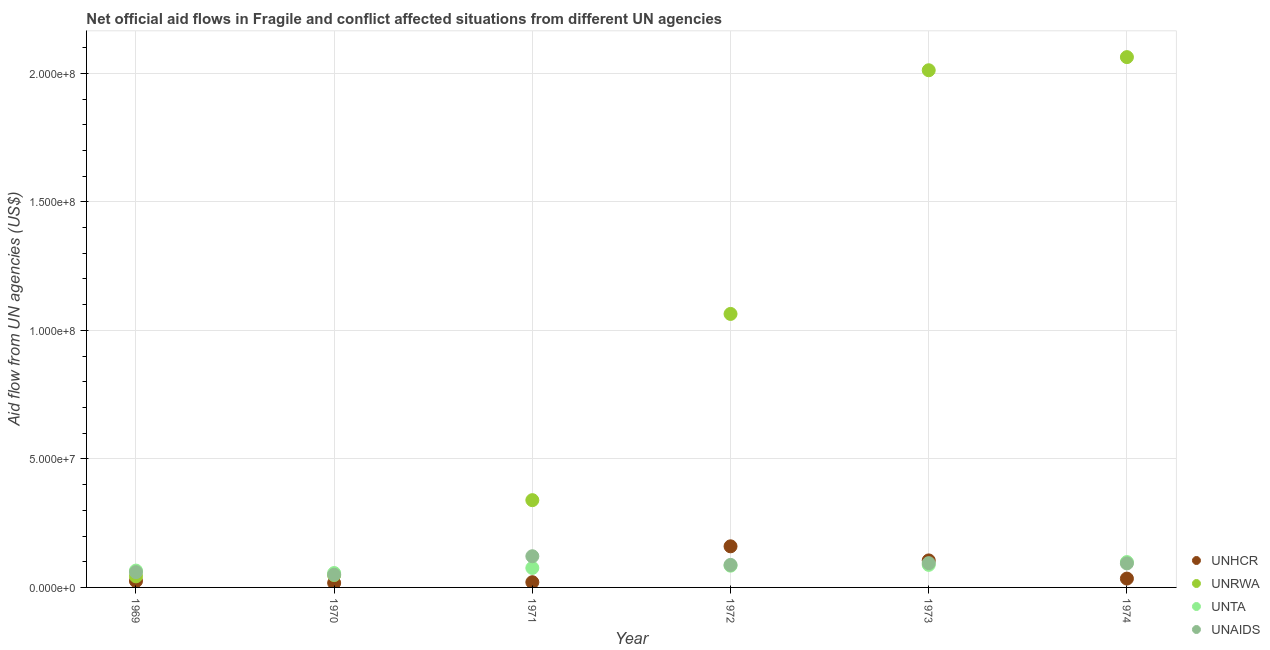What is the amount of aid given by unrwa in 1970?
Your answer should be very brief. 4.79e+06. Across all years, what is the maximum amount of aid given by unhcr?
Keep it short and to the point. 1.60e+07. Across all years, what is the minimum amount of aid given by unaids?
Your response must be concise. 4.94e+06. In which year was the amount of aid given by unta maximum?
Keep it short and to the point. 1974. In which year was the amount of aid given by unhcr minimum?
Offer a very short reply. 1970. What is the total amount of aid given by unrwa in the graph?
Offer a terse response. 5.57e+08. What is the difference between the amount of aid given by unhcr in 1969 and that in 1974?
Your answer should be compact. -9.60e+05. What is the difference between the amount of aid given by unta in 1973 and the amount of aid given by unrwa in 1971?
Make the answer very short. -2.52e+07. What is the average amount of aid given by unta per year?
Ensure brevity in your answer.  7.80e+06. In the year 1970, what is the difference between the amount of aid given by unaids and amount of aid given by unta?
Offer a very short reply. -6.50e+05. In how many years, is the amount of aid given by unta greater than 140000000 US$?
Your answer should be compact. 0. What is the ratio of the amount of aid given by unhcr in 1969 to that in 1972?
Provide a short and direct response. 0.16. What is the difference between the highest and the second highest amount of aid given by unaids?
Give a very brief answer. 2.68e+06. What is the difference between the highest and the lowest amount of aid given by unrwa?
Your answer should be very brief. 2.02e+08. In how many years, is the amount of aid given by unrwa greater than the average amount of aid given by unrwa taken over all years?
Your response must be concise. 3. Is the sum of the amount of aid given by unta in 1970 and 1972 greater than the maximum amount of aid given by unrwa across all years?
Give a very brief answer. No. Is it the case that in every year, the sum of the amount of aid given by unaids and amount of aid given by unta is greater than the sum of amount of aid given by unrwa and amount of aid given by unhcr?
Give a very brief answer. No. Does the amount of aid given by unrwa monotonically increase over the years?
Offer a terse response. Yes. Is the amount of aid given by unrwa strictly less than the amount of aid given by unaids over the years?
Give a very brief answer. No. How many dotlines are there?
Make the answer very short. 4. What is the difference between two consecutive major ticks on the Y-axis?
Offer a terse response. 5.00e+07. Are the values on the major ticks of Y-axis written in scientific E-notation?
Give a very brief answer. Yes. Does the graph contain any zero values?
Provide a short and direct response. No. Does the graph contain grids?
Offer a very short reply. Yes. How are the legend labels stacked?
Keep it short and to the point. Vertical. What is the title of the graph?
Your answer should be compact. Net official aid flows in Fragile and conflict affected situations from different UN agencies. What is the label or title of the X-axis?
Your answer should be compact. Year. What is the label or title of the Y-axis?
Offer a very short reply. Aid flow from UN agencies (US$). What is the Aid flow from UN agencies (US$) of UNHCR in 1969?
Make the answer very short. 2.48e+06. What is the Aid flow from UN agencies (US$) of UNRWA in 1969?
Your answer should be very brief. 4.30e+06. What is the Aid flow from UN agencies (US$) of UNTA in 1969?
Your answer should be compact. 6.55e+06. What is the Aid flow from UN agencies (US$) in UNAIDS in 1969?
Your answer should be very brief. 5.95e+06. What is the Aid flow from UN agencies (US$) of UNHCR in 1970?
Your answer should be compact. 1.74e+06. What is the Aid flow from UN agencies (US$) of UNRWA in 1970?
Make the answer very short. 4.79e+06. What is the Aid flow from UN agencies (US$) in UNTA in 1970?
Make the answer very short. 5.59e+06. What is the Aid flow from UN agencies (US$) in UNAIDS in 1970?
Your answer should be very brief. 4.94e+06. What is the Aid flow from UN agencies (US$) in UNHCR in 1971?
Provide a succinct answer. 2.03e+06. What is the Aid flow from UN agencies (US$) of UNRWA in 1971?
Offer a very short reply. 3.40e+07. What is the Aid flow from UN agencies (US$) in UNTA in 1971?
Make the answer very short. 7.58e+06. What is the Aid flow from UN agencies (US$) in UNAIDS in 1971?
Provide a short and direct response. 1.21e+07. What is the Aid flow from UN agencies (US$) in UNHCR in 1972?
Offer a very short reply. 1.60e+07. What is the Aid flow from UN agencies (US$) in UNRWA in 1972?
Give a very brief answer. 1.06e+08. What is the Aid flow from UN agencies (US$) in UNTA in 1972?
Offer a terse response. 8.46e+06. What is the Aid flow from UN agencies (US$) in UNAIDS in 1972?
Provide a short and direct response. 8.76e+06. What is the Aid flow from UN agencies (US$) in UNHCR in 1973?
Provide a succinct answer. 1.05e+07. What is the Aid flow from UN agencies (US$) of UNRWA in 1973?
Your response must be concise. 2.01e+08. What is the Aid flow from UN agencies (US$) in UNTA in 1973?
Keep it short and to the point. 8.78e+06. What is the Aid flow from UN agencies (US$) of UNAIDS in 1973?
Offer a very short reply. 9.45e+06. What is the Aid flow from UN agencies (US$) of UNHCR in 1974?
Provide a short and direct response. 3.44e+06. What is the Aid flow from UN agencies (US$) in UNRWA in 1974?
Your answer should be very brief. 2.06e+08. What is the Aid flow from UN agencies (US$) in UNTA in 1974?
Your answer should be very brief. 9.86e+06. What is the Aid flow from UN agencies (US$) in UNAIDS in 1974?
Your answer should be compact. 9.35e+06. Across all years, what is the maximum Aid flow from UN agencies (US$) of UNHCR?
Keep it short and to the point. 1.60e+07. Across all years, what is the maximum Aid flow from UN agencies (US$) of UNRWA?
Give a very brief answer. 2.06e+08. Across all years, what is the maximum Aid flow from UN agencies (US$) in UNTA?
Ensure brevity in your answer.  9.86e+06. Across all years, what is the maximum Aid flow from UN agencies (US$) of UNAIDS?
Keep it short and to the point. 1.21e+07. Across all years, what is the minimum Aid flow from UN agencies (US$) in UNHCR?
Keep it short and to the point. 1.74e+06. Across all years, what is the minimum Aid flow from UN agencies (US$) of UNRWA?
Offer a very short reply. 4.30e+06. Across all years, what is the minimum Aid flow from UN agencies (US$) of UNTA?
Provide a short and direct response. 5.59e+06. Across all years, what is the minimum Aid flow from UN agencies (US$) in UNAIDS?
Your response must be concise. 4.94e+06. What is the total Aid flow from UN agencies (US$) in UNHCR in the graph?
Offer a terse response. 3.62e+07. What is the total Aid flow from UN agencies (US$) in UNRWA in the graph?
Your response must be concise. 5.57e+08. What is the total Aid flow from UN agencies (US$) of UNTA in the graph?
Keep it short and to the point. 4.68e+07. What is the total Aid flow from UN agencies (US$) in UNAIDS in the graph?
Keep it short and to the point. 5.06e+07. What is the difference between the Aid flow from UN agencies (US$) in UNHCR in 1969 and that in 1970?
Your answer should be compact. 7.40e+05. What is the difference between the Aid flow from UN agencies (US$) of UNRWA in 1969 and that in 1970?
Provide a short and direct response. -4.90e+05. What is the difference between the Aid flow from UN agencies (US$) of UNTA in 1969 and that in 1970?
Your answer should be compact. 9.60e+05. What is the difference between the Aid flow from UN agencies (US$) of UNAIDS in 1969 and that in 1970?
Your answer should be compact. 1.01e+06. What is the difference between the Aid flow from UN agencies (US$) of UNHCR in 1969 and that in 1971?
Offer a very short reply. 4.50e+05. What is the difference between the Aid flow from UN agencies (US$) of UNRWA in 1969 and that in 1971?
Ensure brevity in your answer.  -2.96e+07. What is the difference between the Aid flow from UN agencies (US$) of UNTA in 1969 and that in 1971?
Ensure brevity in your answer.  -1.03e+06. What is the difference between the Aid flow from UN agencies (US$) of UNAIDS in 1969 and that in 1971?
Ensure brevity in your answer.  -6.18e+06. What is the difference between the Aid flow from UN agencies (US$) in UNHCR in 1969 and that in 1972?
Give a very brief answer. -1.35e+07. What is the difference between the Aid flow from UN agencies (US$) in UNRWA in 1969 and that in 1972?
Keep it short and to the point. -1.02e+08. What is the difference between the Aid flow from UN agencies (US$) in UNTA in 1969 and that in 1972?
Your answer should be compact. -1.91e+06. What is the difference between the Aid flow from UN agencies (US$) of UNAIDS in 1969 and that in 1972?
Your answer should be very brief. -2.81e+06. What is the difference between the Aid flow from UN agencies (US$) of UNHCR in 1969 and that in 1973?
Your answer should be compact. -8.03e+06. What is the difference between the Aid flow from UN agencies (US$) in UNRWA in 1969 and that in 1973?
Your response must be concise. -1.97e+08. What is the difference between the Aid flow from UN agencies (US$) of UNTA in 1969 and that in 1973?
Make the answer very short. -2.23e+06. What is the difference between the Aid flow from UN agencies (US$) in UNAIDS in 1969 and that in 1973?
Offer a terse response. -3.50e+06. What is the difference between the Aid flow from UN agencies (US$) in UNHCR in 1969 and that in 1974?
Offer a very short reply. -9.60e+05. What is the difference between the Aid flow from UN agencies (US$) of UNRWA in 1969 and that in 1974?
Offer a very short reply. -2.02e+08. What is the difference between the Aid flow from UN agencies (US$) of UNTA in 1969 and that in 1974?
Your answer should be very brief. -3.31e+06. What is the difference between the Aid flow from UN agencies (US$) in UNAIDS in 1969 and that in 1974?
Provide a short and direct response. -3.40e+06. What is the difference between the Aid flow from UN agencies (US$) of UNHCR in 1970 and that in 1971?
Your response must be concise. -2.90e+05. What is the difference between the Aid flow from UN agencies (US$) in UNRWA in 1970 and that in 1971?
Provide a short and direct response. -2.92e+07. What is the difference between the Aid flow from UN agencies (US$) in UNTA in 1970 and that in 1971?
Your answer should be compact. -1.99e+06. What is the difference between the Aid flow from UN agencies (US$) in UNAIDS in 1970 and that in 1971?
Ensure brevity in your answer.  -7.19e+06. What is the difference between the Aid flow from UN agencies (US$) of UNHCR in 1970 and that in 1972?
Provide a short and direct response. -1.42e+07. What is the difference between the Aid flow from UN agencies (US$) in UNRWA in 1970 and that in 1972?
Offer a terse response. -1.02e+08. What is the difference between the Aid flow from UN agencies (US$) of UNTA in 1970 and that in 1972?
Offer a very short reply. -2.87e+06. What is the difference between the Aid flow from UN agencies (US$) of UNAIDS in 1970 and that in 1972?
Your answer should be very brief. -3.82e+06. What is the difference between the Aid flow from UN agencies (US$) in UNHCR in 1970 and that in 1973?
Provide a succinct answer. -8.77e+06. What is the difference between the Aid flow from UN agencies (US$) in UNRWA in 1970 and that in 1973?
Ensure brevity in your answer.  -1.96e+08. What is the difference between the Aid flow from UN agencies (US$) of UNTA in 1970 and that in 1973?
Offer a very short reply. -3.19e+06. What is the difference between the Aid flow from UN agencies (US$) of UNAIDS in 1970 and that in 1973?
Make the answer very short. -4.51e+06. What is the difference between the Aid flow from UN agencies (US$) in UNHCR in 1970 and that in 1974?
Give a very brief answer. -1.70e+06. What is the difference between the Aid flow from UN agencies (US$) of UNRWA in 1970 and that in 1974?
Ensure brevity in your answer.  -2.02e+08. What is the difference between the Aid flow from UN agencies (US$) in UNTA in 1970 and that in 1974?
Your answer should be very brief. -4.27e+06. What is the difference between the Aid flow from UN agencies (US$) in UNAIDS in 1970 and that in 1974?
Your answer should be very brief. -4.41e+06. What is the difference between the Aid flow from UN agencies (US$) of UNHCR in 1971 and that in 1972?
Provide a succinct answer. -1.40e+07. What is the difference between the Aid flow from UN agencies (US$) of UNRWA in 1971 and that in 1972?
Make the answer very short. -7.24e+07. What is the difference between the Aid flow from UN agencies (US$) of UNTA in 1971 and that in 1972?
Your response must be concise. -8.80e+05. What is the difference between the Aid flow from UN agencies (US$) of UNAIDS in 1971 and that in 1972?
Ensure brevity in your answer.  3.37e+06. What is the difference between the Aid flow from UN agencies (US$) in UNHCR in 1971 and that in 1973?
Your answer should be compact. -8.48e+06. What is the difference between the Aid flow from UN agencies (US$) of UNRWA in 1971 and that in 1973?
Your answer should be very brief. -1.67e+08. What is the difference between the Aid flow from UN agencies (US$) of UNTA in 1971 and that in 1973?
Your answer should be compact. -1.20e+06. What is the difference between the Aid flow from UN agencies (US$) in UNAIDS in 1971 and that in 1973?
Give a very brief answer. 2.68e+06. What is the difference between the Aid flow from UN agencies (US$) of UNHCR in 1971 and that in 1974?
Make the answer very short. -1.41e+06. What is the difference between the Aid flow from UN agencies (US$) of UNRWA in 1971 and that in 1974?
Your answer should be very brief. -1.72e+08. What is the difference between the Aid flow from UN agencies (US$) of UNTA in 1971 and that in 1974?
Provide a succinct answer. -2.28e+06. What is the difference between the Aid flow from UN agencies (US$) of UNAIDS in 1971 and that in 1974?
Ensure brevity in your answer.  2.78e+06. What is the difference between the Aid flow from UN agencies (US$) in UNHCR in 1972 and that in 1973?
Your answer should be very brief. 5.48e+06. What is the difference between the Aid flow from UN agencies (US$) in UNRWA in 1972 and that in 1973?
Your answer should be very brief. -9.48e+07. What is the difference between the Aid flow from UN agencies (US$) of UNTA in 1972 and that in 1973?
Keep it short and to the point. -3.20e+05. What is the difference between the Aid flow from UN agencies (US$) of UNAIDS in 1972 and that in 1973?
Keep it short and to the point. -6.90e+05. What is the difference between the Aid flow from UN agencies (US$) of UNHCR in 1972 and that in 1974?
Make the answer very short. 1.26e+07. What is the difference between the Aid flow from UN agencies (US$) of UNRWA in 1972 and that in 1974?
Offer a terse response. -9.99e+07. What is the difference between the Aid flow from UN agencies (US$) of UNTA in 1972 and that in 1974?
Offer a terse response. -1.40e+06. What is the difference between the Aid flow from UN agencies (US$) in UNAIDS in 1972 and that in 1974?
Keep it short and to the point. -5.90e+05. What is the difference between the Aid flow from UN agencies (US$) in UNHCR in 1973 and that in 1974?
Keep it short and to the point. 7.07e+06. What is the difference between the Aid flow from UN agencies (US$) of UNRWA in 1973 and that in 1974?
Your answer should be very brief. -5.11e+06. What is the difference between the Aid flow from UN agencies (US$) of UNTA in 1973 and that in 1974?
Keep it short and to the point. -1.08e+06. What is the difference between the Aid flow from UN agencies (US$) of UNHCR in 1969 and the Aid flow from UN agencies (US$) of UNRWA in 1970?
Provide a short and direct response. -2.31e+06. What is the difference between the Aid flow from UN agencies (US$) of UNHCR in 1969 and the Aid flow from UN agencies (US$) of UNTA in 1970?
Ensure brevity in your answer.  -3.11e+06. What is the difference between the Aid flow from UN agencies (US$) of UNHCR in 1969 and the Aid flow from UN agencies (US$) of UNAIDS in 1970?
Give a very brief answer. -2.46e+06. What is the difference between the Aid flow from UN agencies (US$) in UNRWA in 1969 and the Aid flow from UN agencies (US$) in UNTA in 1970?
Make the answer very short. -1.29e+06. What is the difference between the Aid flow from UN agencies (US$) in UNRWA in 1969 and the Aid flow from UN agencies (US$) in UNAIDS in 1970?
Ensure brevity in your answer.  -6.40e+05. What is the difference between the Aid flow from UN agencies (US$) of UNTA in 1969 and the Aid flow from UN agencies (US$) of UNAIDS in 1970?
Offer a very short reply. 1.61e+06. What is the difference between the Aid flow from UN agencies (US$) in UNHCR in 1969 and the Aid flow from UN agencies (US$) in UNRWA in 1971?
Your answer should be very brief. -3.15e+07. What is the difference between the Aid flow from UN agencies (US$) in UNHCR in 1969 and the Aid flow from UN agencies (US$) in UNTA in 1971?
Provide a succinct answer. -5.10e+06. What is the difference between the Aid flow from UN agencies (US$) in UNHCR in 1969 and the Aid flow from UN agencies (US$) in UNAIDS in 1971?
Make the answer very short. -9.65e+06. What is the difference between the Aid flow from UN agencies (US$) in UNRWA in 1969 and the Aid flow from UN agencies (US$) in UNTA in 1971?
Your answer should be very brief. -3.28e+06. What is the difference between the Aid flow from UN agencies (US$) of UNRWA in 1969 and the Aid flow from UN agencies (US$) of UNAIDS in 1971?
Keep it short and to the point. -7.83e+06. What is the difference between the Aid flow from UN agencies (US$) in UNTA in 1969 and the Aid flow from UN agencies (US$) in UNAIDS in 1971?
Offer a terse response. -5.58e+06. What is the difference between the Aid flow from UN agencies (US$) of UNHCR in 1969 and the Aid flow from UN agencies (US$) of UNRWA in 1972?
Provide a succinct answer. -1.04e+08. What is the difference between the Aid flow from UN agencies (US$) in UNHCR in 1969 and the Aid flow from UN agencies (US$) in UNTA in 1972?
Keep it short and to the point. -5.98e+06. What is the difference between the Aid flow from UN agencies (US$) in UNHCR in 1969 and the Aid flow from UN agencies (US$) in UNAIDS in 1972?
Provide a short and direct response. -6.28e+06. What is the difference between the Aid flow from UN agencies (US$) of UNRWA in 1969 and the Aid flow from UN agencies (US$) of UNTA in 1972?
Your answer should be compact. -4.16e+06. What is the difference between the Aid flow from UN agencies (US$) of UNRWA in 1969 and the Aid flow from UN agencies (US$) of UNAIDS in 1972?
Provide a succinct answer. -4.46e+06. What is the difference between the Aid flow from UN agencies (US$) in UNTA in 1969 and the Aid flow from UN agencies (US$) in UNAIDS in 1972?
Offer a very short reply. -2.21e+06. What is the difference between the Aid flow from UN agencies (US$) of UNHCR in 1969 and the Aid flow from UN agencies (US$) of UNRWA in 1973?
Make the answer very short. -1.99e+08. What is the difference between the Aid flow from UN agencies (US$) in UNHCR in 1969 and the Aid flow from UN agencies (US$) in UNTA in 1973?
Offer a very short reply. -6.30e+06. What is the difference between the Aid flow from UN agencies (US$) of UNHCR in 1969 and the Aid flow from UN agencies (US$) of UNAIDS in 1973?
Your response must be concise. -6.97e+06. What is the difference between the Aid flow from UN agencies (US$) of UNRWA in 1969 and the Aid flow from UN agencies (US$) of UNTA in 1973?
Your answer should be compact. -4.48e+06. What is the difference between the Aid flow from UN agencies (US$) of UNRWA in 1969 and the Aid flow from UN agencies (US$) of UNAIDS in 1973?
Offer a very short reply. -5.15e+06. What is the difference between the Aid flow from UN agencies (US$) in UNTA in 1969 and the Aid flow from UN agencies (US$) in UNAIDS in 1973?
Keep it short and to the point. -2.90e+06. What is the difference between the Aid flow from UN agencies (US$) in UNHCR in 1969 and the Aid flow from UN agencies (US$) in UNRWA in 1974?
Provide a succinct answer. -2.04e+08. What is the difference between the Aid flow from UN agencies (US$) of UNHCR in 1969 and the Aid flow from UN agencies (US$) of UNTA in 1974?
Ensure brevity in your answer.  -7.38e+06. What is the difference between the Aid flow from UN agencies (US$) of UNHCR in 1969 and the Aid flow from UN agencies (US$) of UNAIDS in 1974?
Make the answer very short. -6.87e+06. What is the difference between the Aid flow from UN agencies (US$) of UNRWA in 1969 and the Aid flow from UN agencies (US$) of UNTA in 1974?
Make the answer very short. -5.56e+06. What is the difference between the Aid flow from UN agencies (US$) of UNRWA in 1969 and the Aid flow from UN agencies (US$) of UNAIDS in 1974?
Make the answer very short. -5.05e+06. What is the difference between the Aid flow from UN agencies (US$) of UNTA in 1969 and the Aid flow from UN agencies (US$) of UNAIDS in 1974?
Offer a very short reply. -2.80e+06. What is the difference between the Aid flow from UN agencies (US$) in UNHCR in 1970 and the Aid flow from UN agencies (US$) in UNRWA in 1971?
Offer a terse response. -3.22e+07. What is the difference between the Aid flow from UN agencies (US$) of UNHCR in 1970 and the Aid flow from UN agencies (US$) of UNTA in 1971?
Ensure brevity in your answer.  -5.84e+06. What is the difference between the Aid flow from UN agencies (US$) in UNHCR in 1970 and the Aid flow from UN agencies (US$) in UNAIDS in 1971?
Offer a very short reply. -1.04e+07. What is the difference between the Aid flow from UN agencies (US$) in UNRWA in 1970 and the Aid flow from UN agencies (US$) in UNTA in 1971?
Ensure brevity in your answer.  -2.79e+06. What is the difference between the Aid flow from UN agencies (US$) of UNRWA in 1970 and the Aid flow from UN agencies (US$) of UNAIDS in 1971?
Make the answer very short. -7.34e+06. What is the difference between the Aid flow from UN agencies (US$) in UNTA in 1970 and the Aid flow from UN agencies (US$) in UNAIDS in 1971?
Give a very brief answer. -6.54e+06. What is the difference between the Aid flow from UN agencies (US$) of UNHCR in 1970 and the Aid flow from UN agencies (US$) of UNRWA in 1972?
Your answer should be compact. -1.05e+08. What is the difference between the Aid flow from UN agencies (US$) of UNHCR in 1970 and the Aid flow from UN agencies (US$) of UNTA in 1972?
Provide a short and direct response. -6.72e+06. What is the difference between the Aid flow from UN agencies (US$) of UNHCR in 1970 and the Aid flow from UN agencies (US$) of UNAIDS in 1972?
Give a very brief answer. -7.02e+06. What is the difference between the Aid flow from UN agencies (US$) in UNRWA in 1970 and the Aid flow from UN agencies (US$) in UNTA in 1972?
Your response must be concise. -3.67e+06. What is the difference between the Aid flow from UN agencies (US$) in UNRWA in 1970 and the Aid flow from UN agencies (US$) in UNAIDS in 1972?
Ensure brevity in your answer.  -3.97e+06. What is the difference between the Aid flow from UN agencies (US$) of UNTA in 1970 and the Aid flow from UN agencies (US$) of UNAIDS in 1972?
Make the answer very short. -3.17e+06. What is the difference between the Aid flow from UN agencies (US$) in UNHCR in 1970 and the Aid flow from UN agencies (US$) in UNRWA in 1973?
Ensure brevity in your answer.  -1.99e+08. What is the difference between the Aid flow from UN agencies (US$) of UNHCR in 1970 and the Aid flow from UN agencies (US$) of UNTA in 1973?
Provide a short and direct response. -7.04e+06. What is the difference between the Aid flow from UN agencies (US$) of UNHCR in 1970 and the Aid flow from UN agencies (US$) of UNAIDS in 1973?
Give a very brief answer. -7.71e+06. What is the difference between the Aid flow from UN agencies (US$) of UNRWA in 1970 and the Aid flow from UN agencies (US$) of UNTA in 1973?
Your answer should be compact. -3.99e+06. What is the difference between the Aid flow from UN agencies (US$) in UNRWA in 1970 and the Aid flow from UN agencies (US$) in UNAIDS in 1973?
Give a very brief answer. -4.66e+06. What is the difference between the Aid flow from UN agencies (US$) of UNTA in 1970 and the Aid flow from UN agencies (US$) of UNAIDS in 1973?
Make the answer very short. -3.86e+06. What is the difference between the Aid flow from UN agencies (US$) in UNHCR in 1970 and the Aid flow from UN agencies (US$) in UNRWA in 1974?
Your answer should be very brief. -2.05e+08. What is the difference between the Aid flow from UN agencies (US$) in UNHCR in 1970 and the Aid flow from UN agencies (US$) in UNTA in 1974?
Offer a very short reply. -8.12e+06. What is the difference between the Aid flow from UN agencies (US$) in UNHCR in 1970 and the Aid flow from UN agencies (US$) in UNAIDS in 1974?
Keep it short and to the point. -7.61e+06. What is the difference between the Aid flow from UN agencies (US$) of UNRWA in 1970 and the Aid flow from UN agencies (US$) of UNTA in 1974?
Ensure brevity in your answer.  -5.07e+06. What is the difference between the Aid flow from UN agencies (US$) of UNRWA in 1970 and the Aid flow from UN agencies (US$) of UNAIDS in 1974?
Offer a terse response. -4.56e+06. What is the difference between the Aid flow from UN agencies (US$) of UNTA in 1970 and the Aid flow from UN agencies (US$) of UNAIDS in 1974?
Make the answer very short. -3.76e+06. What is the difference between the Aid flow from UN agencies (US$) in UNHCR in 1971 and the Aid flow from UN agencies (US$) in UNRWA in 1972?
Provide a short and direct response. -1.04e+08. What is the difference between the Aid flow from UN agencies (US$) of UNHCR in 1971 and the Aid flow from UN agencies (US$) of UNTA in 1972?
Keep it short and to the point. -6.43e+06. What is the difference between the Aid flow from UN agencies (US$) of UNHCR in 1971 and the Aid flow from UN agencies (US$) of UNAIDS in 1972?
Provide a short and direct response. -6.73e+06. What is the difference between the Aid flow from UN agencies (US$) of UNRWA in 1971 and the Aid flow from UN agencies (US$) of UNTA in 1972?
Offer a very short reply. 2.55e+07. What is the difference between the Aid flow from UN agencies (US$) of UNRWA in 1971 and the Aid flow from UN agencies (US$) of UNAIDS in 1972?
Ensure brevity in your answer.  2.52e+07. What is the difference between the Aid flow from UN agencies (US$) in UNTA in 1971 and the Aid flow from UN agencies (US$) in UNAIDS in 1972?
Offer a terse response. -1.18e+06. What is the difference between the Aid flow from UN agencies (US$) of UNHCR in 1971 and the Aid flow from UN agencies (US$) of UNRWA in 1973?
Your answer should be very brief. -1.99e+08. What is the difference between the Aid flow from UN agencies (US$) in UNHCR in 1971 and the Aid flow from UN agencies (US$) in UNTA in 1973?
Provide a short and direct response. -6.75e+06. What is the difference between the Aid flow from UN agencies (US$) of UNHCR in 1971 and the Aid flow from UN agencies (US$) of UNAIDS in 1973?
Provide a short and direct response. -7.42e+06. What is the difference between the Aid flow from UN agencies (US$) in UNRWA in 1971 and the Aid flow from UN agencies (US$) in UNTA in 1973?
Make the answer very short. 2.52e+07. What is the difference between the Aid flow from UN agencies (US$) of UNRWA in 1971 and the Aid flow from UN agencies (US$) of UNAIDS in 1973?
Your answer should be compact. 2.45e+07. What is the difference between the Aid flow from UN agencies (US$) of UNTA in 1971 and the Aid flow from UN agencies (US$) of UNAIDS in 1973?
Provide a short and direct response. -1.87e+06. What is the difference between the Aid flow from UN agencies (US$) in UNHCR in 1971 and the Aid flow from UN agencies (US$) in UNRWA in 1974?
Give a very brief answer. -2.04e+08. What is the difference between the Aid flow from UN agencies (US$) of UNHCR in 1971 and the Aid flow from UN agencies (US$) of UNTA in 1974?
Keep it short and to the point. -7.83e+06. What is the difference between the Aid flow from UN agencies (US$) in UNHCR in 1971 and the Aid flow from UN agencies (US$) in UNAIDS in 1974?
Your answer should be very brief. -7.32e+06. What is the difference between the Aid flow from UN agencies (US$) of UNRWA in 1971 and the Aid flow from UN agencies (US$) of UNTA in 1974?
Your answer should be very brief. 2.41e+07. What is the difference between the Aid flow from UN agencies (US$) in UNRWA in 1971 and the Aid flow from UN agencies (US$) in UNAIDS in 1974?
Your answer should be compact. 2.46e+07. What is the difference between the Aid flow from UN agencies (US$) of UNTA in 1971 and the Aid flow from UN agencies (US$) of UNAIDS in 1974?
Your response must be concise. -1.77e+06. What is the difference between the Aid flow from UN agencies (US$) in UNHCR in 1972 and the Aid flow from UN agencies (US$) in UNRWA in 1973?
Provide a succinct answer. -1.85e+08. What is the difference between the Aid flow from UN agencies (US$) in UNHCR in 1972 and the Aid flow from UN agencies (US$) in UNTA in 1973?
Provide a short and direct response. 7.21e+06. What is the difference between the Aid flow from UN agencies (US$) in UNHCR in 1972 and the Aid flow from UN agencies (US$) in UNAIDS in 1973?
Give a very brief answer. 6.54e+06. What is the difference between the Aid flow from UN agencies (US$) of UNRWA in 1972 and the Aid flow from UN agencies (US$) of UNTA in 1973?
Your answer should be very brief. 9.76e+07. What is the difference between the Aid flow from UN agencies (US$) in UNRWA in 1972 and the Aid flow from UN agencies (US$) in UNAIDS in 1973?
Your response must be concise. 9.70e+07. What is the difference between the Aid flow from UN agencies (US$) of UNTA in 1972 and the Aid flow from UN agencies (US$) of UNAIDS in 1973?
Ensure brevity in your answer.  -9.90e+05. What is the difference between the Aid flow from UN agencies (US$) in UNHCR in 1972 and the Aid flow from UN agencies (US$) in UNRWA in 1974?
Provide a succinct answer. -1.90e+08. What is the difference between the Aid flow from UN agencies (US$) in UNHCR in 1972 and the Aid flow from UN agencies (US$) in UNTA in 1974?
Your answer should be very brief. 6.13e+06. What is the difference between the Aid flow from UN agencies (US$) of UNHCR in 1972 and the Aid flow from UN agencies (US$) of UNAIDS in 1974?
Make the answer very short. 6.64e+06. What is the difference between the Aid flow from UN agencies (US$) in UNRWA in 1972 and the Aid flow from UN agencies (US$) in UNTA in 1974?
Give a very brief answer. 9.65e+07. What is the difference between the Aid flow from UN agencies (US$) in UNRWA in 1972 and the Aid flow from UN agencies (US$) in UNAIDS in 1974?
Your answer should be very brief. 9.70e+07. What is the difference between the Aid flow from UN agencies (US$) in UNTA in 1972 and the Aid flow from UN agencies (US$) in UNAIDS in 1974?
Make the answer very short. -8.90e+05. What is the difference between the Aid flow from UN agencies (US$) of UNHCR in 1973 and the Aid flow from UN agencies (US$) of UNRWA in 1974?
Keep it short and to the point. -1.96e+08. What is the difference between the Aid flow from UN agencies (US$) in UNHCR in 1973 and the Aid flow from UN agencies (US$) in UNTA in 1974?
Keep it short and to the point. 6.50e+05. What is the difference between the Aid flow from UN agencies (US$) in UNHCR in 1973 and the Aid flow from UN agencies (US$) in UNAIDS in 1974?
Give a very brief answer. 1.16e+06. What is the difference between the Aid flow from UN agencies (US$) in UNRWA in 1973 and the Aid flow from UN agencies (US$) in UNTA in 1974?
Offer a terse response. 1.91e+08. What is the difference between the Aid flow from UN agencies (US$) of UNRWA in 1973 and the Aid flow from UN agencies (US$) of UNAIDS in 1974?
Your answer should be compact. 1.92e+08. What is the difference between the Aid flow from UN agencies (US$) of UNTA in 1973 and the Aid flow from UN agencies (US$) of UNAIDS in 1974?
Your answer should be compact. -5.70e+05. What is the average Aid flow from UN agencies (US$) in UNHCR per year?
Your answer should be very brief. 6.03e+06. What is the average Aid flow from UN agencies (US$) in UNRWA per year?
Provide a short and direct response. 9.28e+07. What is the average Aid flow from UN agencies (US$) of UNTA per year?
Provide a succinct answer. 7.80e+06. What is the average Aid flow from UN agencies (US$) in UNAIDS per year?
Provide a succinct answer. 8.43e+06. In the year 1969, what is the difference between the Aid flow from UN agencies (US$) in UNHCR and Aid flow from UN agencies (US$) in UNRWA?
Offer a terse response. -1.82e+06. In the year 1969, what is the difference between the Aid flow from UN agencies (US$) of UNHCR and Aid flow from UN agencies (US$) of UNTA?
Offer a very short reply. -4.07e+06. In the year 1969, what is the difference between the Aid flow from UN agencies (US$) of UNHCR and Aid flow from UN agencies (US$) of UNAIDS?
Your response must be concise. -3.47e+06. In the year 1969, what is the difference between the Aid flow from UN agencies (US$) of UNRWA and Aid flow from UN agencies (US$) of UNTA?
Provide a short and direct response. -2.25e+06. In the year 1969, what is the difference between the Aid flow from UN agencies (US$) of UNRWA and Aid flow from UN agencies (US$) of UNAIDS?
Offer a terse response. -1.65e+06. In the year 1970, what is the difference between the Aid flow from UN agencies (US$) of UNHCR and Aid flow from UN agencies (US$) of UNRWA?
Your answer should be compact. -3.05e+06. In the year 1970, what is the difference between the Aid flow from UN agencies (US$) in UNHCR and Aid flow from UN agencies (US$) in UNTA?
Your response must be concise. -3.85e+06. In the year 1970, what is the difference between the Aid flow from UN agencies (US$) in UNHCR and Aid flow from UN agencies (US$) in UNAIDS?
Make the answer very short. -3.20e+06. In the year 1970, what is the difference between the Aid flow from UN agencies (US$) in UNRWA and Aid flow from UN agencies (US$) in UNTA?
Provide a short and direct response. -8.00e+05. In the year 1970, what is the difference between the Aid flow from UN agencies (US$) in UNRWA and Aid flow from UN agencies (US$) in UNAIDS?
Your response must be concise. -1.50e+05. In the year 1970, what is the difference between the Aid flow from UN agencies (US$) in UNTA and Aid flow from UN agencies (US$) in UNAIDS?
Provide a succinct answer. 6.50e+05. In the year 1971, what is the difference between the Aid flow from UN agencies (US$) in UNHCR and Aid flow from UN agencies (US$) in UNRWA?
Your response must be concise. -3.19e+07. In the year 1971, what is the difference between the Aid flow from UN agencies (US$) of UNHCR and Aid flow from UN agencies (US$) of UNTA?
Provide a short and direct response. -5.55e+06. In the year 1971, what is the difference between the Aid flow from UN agencies (US$) of UNHCR and Aid flow from UN agencies (US$) of UNAIDS?
Offer a very short reply. -1.01e+07. In the year 1971, what is the difference between the Aid flow from UN agencies (US$) of UNRWA and Aid flow from UN agencies (US$) of UNTA?
Offer a very short reply. 2.64e+07. In the year 1971, what is the difference between the Aid flow from UN agencies (US$) of UNRWA and Aid flow from UN agencies (US$) of UNAIDS?
Your answer should be compact. 2.18e+07. In the year 1971, what is the difference between the Aid flow from UN agencies (US$) in UNTA and Aid flow from UN agencies (US$) in UNAIDS?
Offer a terse response. -4.55e+06. In the year 1972, what is the difference between the Aid flow from UN agencies (US$) in UNHCR and Aid flow from UN agencies (US$) in UNRWA?
Give a very brief answer. -9.04e+07. In the year 1972, what is the difference between the Aid flow from UN agencies (US$) in UNHCR and Aid flow from UN agencies (US$) in UNTA?
Offer a very short reply. 7.53e+06. In the year 1972, what is the difference between the Aid flow from UN agencies (US$) in UNHCR and Aid flow from UN agencies (US$) in UNAIDS?
Give a very brief answer. 7.23e+06. In the year 1972, what is the difference between the Aid flow from UN agencies (US$) of UNRWA and Aid flow from UN agencies (US$) of UNTA?
Offer a very short reply. 9.79e+07. In the year 1972, what is the difference between the Aid flow from UN agencies (US$) in UNRWA and Aid flow from UN agencies (US$) in UNAIDS?
Keep it short and to the point. 9.76e+07. In the year 1972, what is the difference between the Aid flow from UN agencies (US$) in UNTA and Aid flow from UN agencies (US$) in UNAIDS?
Offer a terse response. -3.00e+05. In the year 1973, what is the difference between the Aid flow from UN agencies (US$) of UNHCR and Aid flow from UN agencies (US$) of UNRWA?
Your answer should be compact. -1.91e+08. In the year 1973, what is the difference between the Aid flow from UN agencies (US$) in UNHCR and Aid flow from UN agencies (US$) in UNTA?
Offer a very short reply. 1.73e+06. In the year 1973, what is the difference between the Aid flow from UN agencies (US$) of UNHCR and Aid flow from UN agencies (US$) of UNAIDS?
Your answer should be compact. 1.06e+06. In the year 1973, what is the difference between the Aid flow from UN agencies (US$) in UNRWA and Aid flow from UN agencies (US$) in UNTA?
Your response must be concise. 1.92e+08. In the year 1973, what is the difference between the Aid flow from UN agencies (US$) in UNRWA and Aid flow from UN agencies (US$) in UNAIDS?
Keep it short and to the point. 1.92e+08. In the year 1973, what is the difference between the Aid flow from UN agencies (US$) of UNTA and Aid flow from UN agencies (US$) of UNAIDS?
Give a very brief answer. -6.70e+05. In the year 1974, what is the difference between the Aid flow from UN agencies (US$) in UNHCR and Aid flow from UN agencies (US$) in UNRWA?
Offer a terse response. -2.03e+08. In the year 1974, what is the difference between the Aid flow from UN agencies (US$) in UNHCR and Aid flow from UN agencies (US$) in UNTA?
Keep it short and to the point. -6.42e+06. In the year 1974, what is the difference between the Aid flow from UN agencies (US$) of UNHCR and Aid flow from UN agencies (US$) of UNAIDS?
Your response must be concise. -5.91e+06. In the year 1974, what is the difference between the Aid flow from UN agencies (US$) in UNRWA and Aid flow from UN agencies (US$) in UNTA?
Your answer should be compact. 1.96e+08. In the year 1974, what is the difference between the Aid flow from UN agencies (US$) in UNRWA and Aid flow from UN agencies (US$) in UNAIDS?
Offer a very short reply. 1.97e+08. In the year 1974, what is the difference between the Aid flow from UN agencies (US$) of UNTA and Aid flow from UN agencies (US$) of UNAIDS?
Give a very brief answer. 5.10e+05. What is the ratio of the Aid flow from UN agencies (US$) in UNHCR in 1969 to that in 1970?
Make the answer very short. 1.43. What is the ratio of the Aid flow from UN agencies (US$) of UNRWA in 1969 to that in 1970?
Your answer should be very brief. 0.9. What is the ratio of the Aid flow from UN agencies (US$) in UNTA in 1969 to that in 1970?
Give a very brief answer. 1.17. What is the ratio of the Aid flow from UN agencies (US$) in UNAIDS in 1969 to that in 1970?
Give a very brief answer. 1.2. What is the ratio of the Aid flow from UN agencies (US$) in UNHCR in 1969 to that in 1971?
Offer a very short reply. 1.22. What is the ratio of the Aid flow from UN agencies (US$) of UNRWA in 1969 to that in 1971?
Ensure brevity in your answer.  0.13. What is the ratio of the Aid flow from UN agencies (US$) in UNTA in 1969 to that in 1971?
Make the answer very short. 0.86. What is the ratio of the Aid flow from UN agencies (US$) of UNAIDS in 1969 to that in 1971?
Provide a succinct answer. 0.49. What is the ratio of the Aid flow from UN agencies (US$) in UNHCR in 1969 to that in 1972?
Your response must be concise. 0.16. What is the ratio of the Aid flow from UN agencies (US$) in UNRWA in 1969 to that in 1972?
Give a very brief answer. 0.04. What is the ratio of the Aid flow from UN agencies (US$) of UNTA in 1969 to that in 1972?
Provide a short and direct response. 0.77. What is the ratio of the Aid flow from UN agencies (US$) in UNAIDS in 1969 to that in 1972?
Provide a succinct answer. 0.68. What is the ratio of the Aid flow from UN agencies (US$) in UNHCR in 1969 to that in 1973?
Offer a very short reply. 0.24. What is the ratio of the Aid flow from UN agencies (US$) of UNRWA in 1969 to that in 1973?
Offer a terse response. 0.02. What is the ratio of the Aid flow from UN agencies (US$) in UNTA in 1969 to that in 1973?
Offer a terse response. 0.75. What is the ratio of the Aid flow from UN agencies (US$) of UNAIDS in 1969 to that in 1973?
Give a very brief answer. 0.63. What is the ratio of the Aid flow from UN agencies (US$) of UNHCR in 1969 to that in 1974?
Offer a terse response. 0.72. What is the ratio of the Aid flow from UN agencies (US$) in UNRWA in 1969 to that in 1974?
Give a very brief answer. 0.02. What is the ratio of the Aid flow from UN agencies (US$) in UNTA in 1969 to that in 1974?
Give a very brief answer. 0.66. What is the ratio of the Aid flow from UN agencies (US$) in UNAIDS in 1969 to that in 1974?
Offer a terse response. 0.64. What is the ratio of the Aid flow from UN agencies (US$) of UNRWA in 1970 to that in 1971?
Your response must be concise. 0.14. What is the ratio of the Aid flow from UN agencies (US$) in UNTA in 1970 to that in 1971?
Your answer should be compact. 0.74. What is the ratio of the Aid flow from UN agencies (US$) of UNAIDS in 1970 to that in 1971?
Offer a very short reply. 0.41. What is the ratio of the Aid flow from UN agencies (US$) in UNHCR in 1970 to that in 1972?
Provide a short and direct response. 0.11. What is the ratio of the Aid flow from UN agencies (US$) of UNRWA in 1970 to that in 1972?
Keep it short and to the point. 0.04. What is the ratio of the Aid flow from UN agencies (US$) in UNTA in 1970 to that in 1972?
Keep it short and to the point. 0.66. What is the ratio of the Aid flow from UN agencies (US$) of UNAIDS in 1970 to that in 1972?
Offer a very short reply. 0.56. What is the ratio of the Aid flow from UN agencies (US$) in UNHCR in 1970 to that in 1973?
Provide a succinct answer. 0.17. What is the ratio of the Aid flow from UN agencies (US$) of UNRWA in 1970 to that in 1973?
Offer a terse response. 0.02. What is the ratio of the Aid flow from UN agencies (US$) of UNTA in 1970 to that in 1973?
Make the answer very short. 0.64. What is the ratio of the Aid flow from UN agencies (US$) of UNAIDS in 1970 to that in 1973?
Give a very brief answer. 0.52. What is the ratio of the Aid flow from UN agencies (US$) in UNHCR in 1970 to that in 1974?
Provide a short and direct response. 0.51. What is the ratio of the Aid flow from UN agencies (US$) in UNRWA in 1970 to that in 1974?
Provide a succinct answer. 0.02. What is the ratio of the Aid flow from UN agencies (US$) of UNTA in 1970 to that in 1974?
Ensure brevity in your answer.  0.57. What is the ratio of the Aid flow from UN agencies (US$) in UNAIDS in 1970 to that in 1974?
Offer a terse response. 0.53. What is the ratio of the Aid flow from UN agencies (US$) in UNHCR in 1971 to that in 1972?
Provide a succinct answer. 0.13. What is the ratio of the Aid flow from UN agencies (US$) in UNRWA in 1971 to that in 1972?
Make the answer very short. 0.32. What is the ratio of the Aid flow from UN agencies (US$) in UNTA in 1971 to that in 1972?
Offer a very short reply. 0.9. What is the ratio of the Aid flow from UN agencies (US$) of UNAIDS in 1971 to that in 1972?
Provide a short and direct response. 1.38. What is the ratio of the Aid flow from UN agencies (US$) in UNHCR in 1971 to that in 1973?
Provide a short and direct response. 0.19. What is the ratio of the Aid flow from UN agencies (US$) of UNRWA in 1971 to that in 1973?
Your answer should be compact. 0.17. What is the ratio of the Aid flow from UN agencies (US$) in UNTA in 1971 to that in 1973?
Your answer should be compact. 0.86. What is the ratio of the Aid flow from UN agencies (US$) of UNAIDS in 1971 to that in 1973?
Give a very brief answer. 1.28. What is the ratio of the Aid flow from UN agencies (US$) in UNHCR in 1971 to that in 1974?
Provide a succinct answer. 0.59. What is the ratio of the Aid flow from UN agencies (US$) of UNRWA in 1971 to that in 1974?
Your answer should be very brief. 0.16. What is the ratio of the Aid flow from UN agencies (US$) in UNTA in 1971 to that in 1974?
Ensure brevity in your answer.  0.77. What is the ratio of the Aid flow from UN agencies (US$) of UNAIDS in 1971 to that in 1974?
Give a very brief answer. 1.3. What is the ratio of the Aid flow from UN agencies (US$) in UNHCR in 1972 to that in 1973?
Offer a terse response. 1.52. What is the ratio of the Aid flow from UN agencies (US$) in UNRWA in 1972 to that in 1973?
Make the answer very short. 0.53. What is the ratio of the Aid flow from UN agencies (US$) in UNTA in 1972 to that in 1973?
Provide a succinct answer. 0.96. What is the ratio of the Aid flow from UN agencies (US$) in UNAIDS in 1972 to that in 1973?
Make the answer very short. 0.93. What is the ratio of the Aid flow from UN agencies (US$) in UNHCR in 1972 to that in 1974?
Provide a succinct answer. 4.65. What is the ratio of the Aid flow from UN agencies (US$) in UNRWA in 1972 to that in 1974?
Your answer should be compact. 0.52. What is the ratio of the Aid flow from UN agencies (US$) of UNTA in 1972 to that in 1974?
Your answer should be compact. 0.86. What is the ratio of the Aid flow from UN agencies (US$) of UNAIDS in 1972 to that in 1974?
Keep it short and to the point. 0.94. What is the ratio of the Aid flow from UN agencies (US$) in UNHCR in 1973 to that in 1974?
Your response must be concise. 3.06. What is the ratio of the Aid flow from UN agencies (US$) of UNRWA in 1973 to that in 1974?
Provide a succinct answer. 0.98. What is the ratio of the Aid flow from UN agencies (US$) of UNTA in 1973 to that in 1974?
Your response must be concise. 0.89. What is the ratio of the Aid flow from UN agencies (US$) in UNAIDS in 1973 to that in 1974?
Your answer should be compact. 1.01. What is the difference between the highest and the second highest Aid flow from UN agencies (US$) in UNHCR?
Give a very brief answer. 5.48e+06. What is the difference between the highest and the second highest Aid flow from UN agencies (US$) in UNRWA?
Give a very brief answer. 5.11e+06. What is the difference between the highest and the second highest Aid flow from UN agencies (US$) in UNTA?
Make the answer very short. 1.08e+06. What is the difference between the highest and the second highest Aid flow from UN agencies (US$) of UNAIDS?
Your answer should be very brief. 2.68e+06. What is the difference between the highest and the lowest Aid flow from UN agencies (US$) in UNHCR?
Ensure brevity in your answer.  1.42e+07. What is the difference between the highest and the lowest Aid flow from UN agencies (US$) in UNRWA?
Your answer should be very brief. 2.02e+08. What is the difference between the highest and the lowest Aid flow from UN agencies (US$) of UNTA?
Provide a succinct answer. 4.27e+06. What is the difference between the highest and the lowest Aid flow from UN agencies (US$) in UNAIDS?
Give a very brief answer. 7.19e+06. 